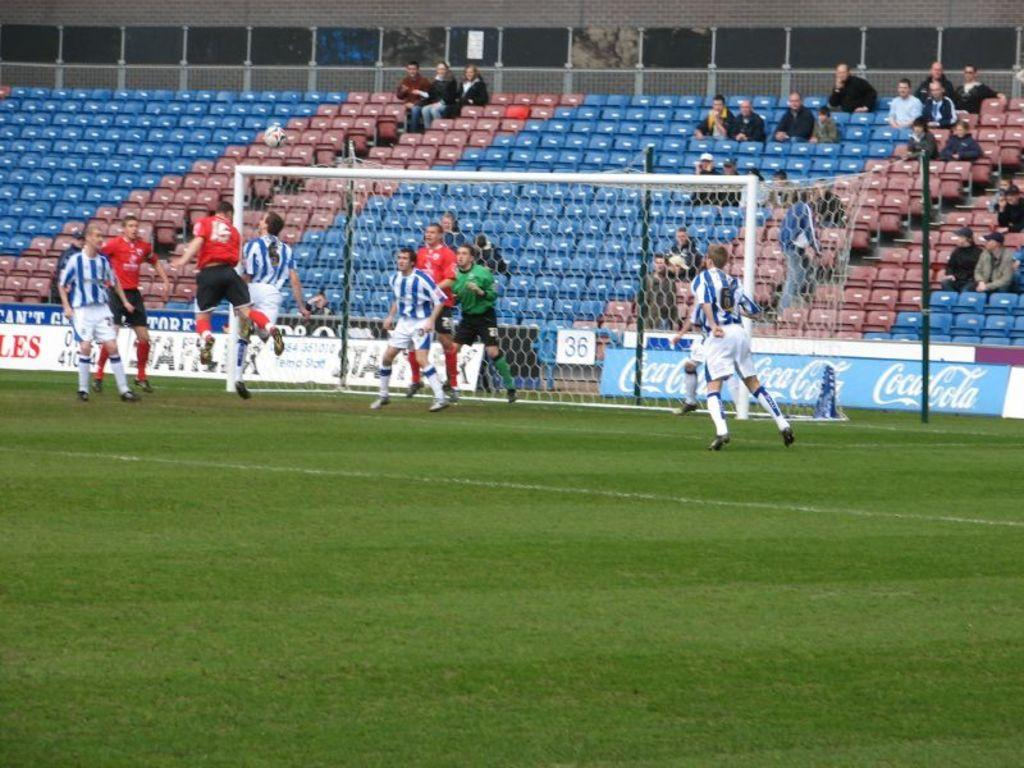<image>
Render a clear and concise summary of the photo. group of men playing soccer and a few people watching 